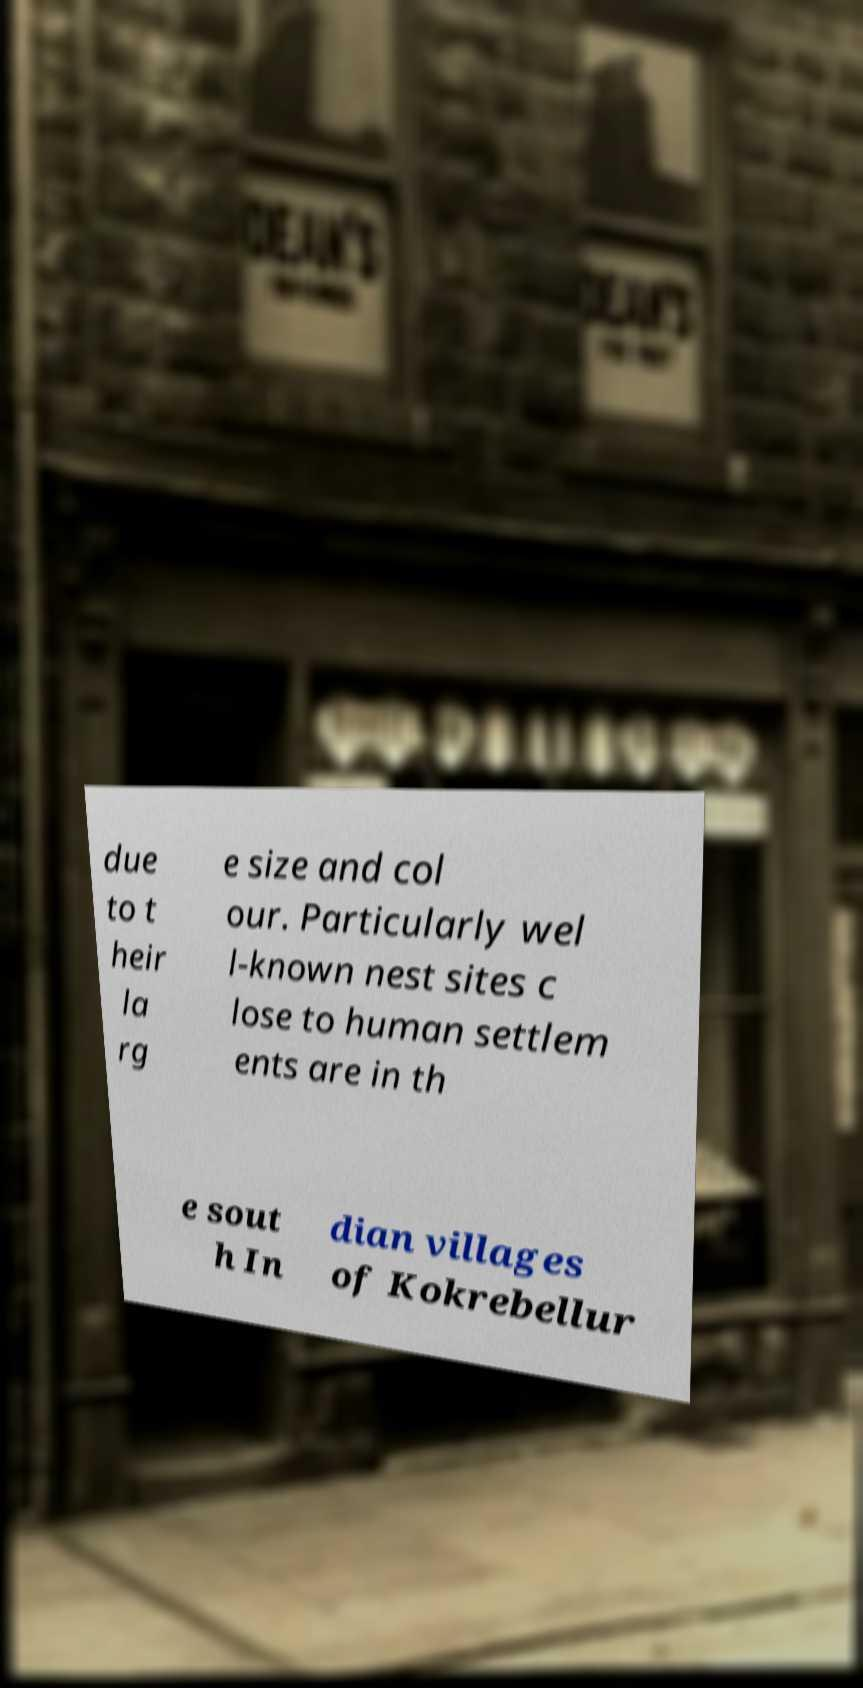There's text embedded in this image that I need extracted. Can you transcribe it verbatim? due to t heir la rg e size and col our. Particularly wel l-known nest sites c lose to human settlem ents are in th e sout h In dian villages of Kokrebellur 